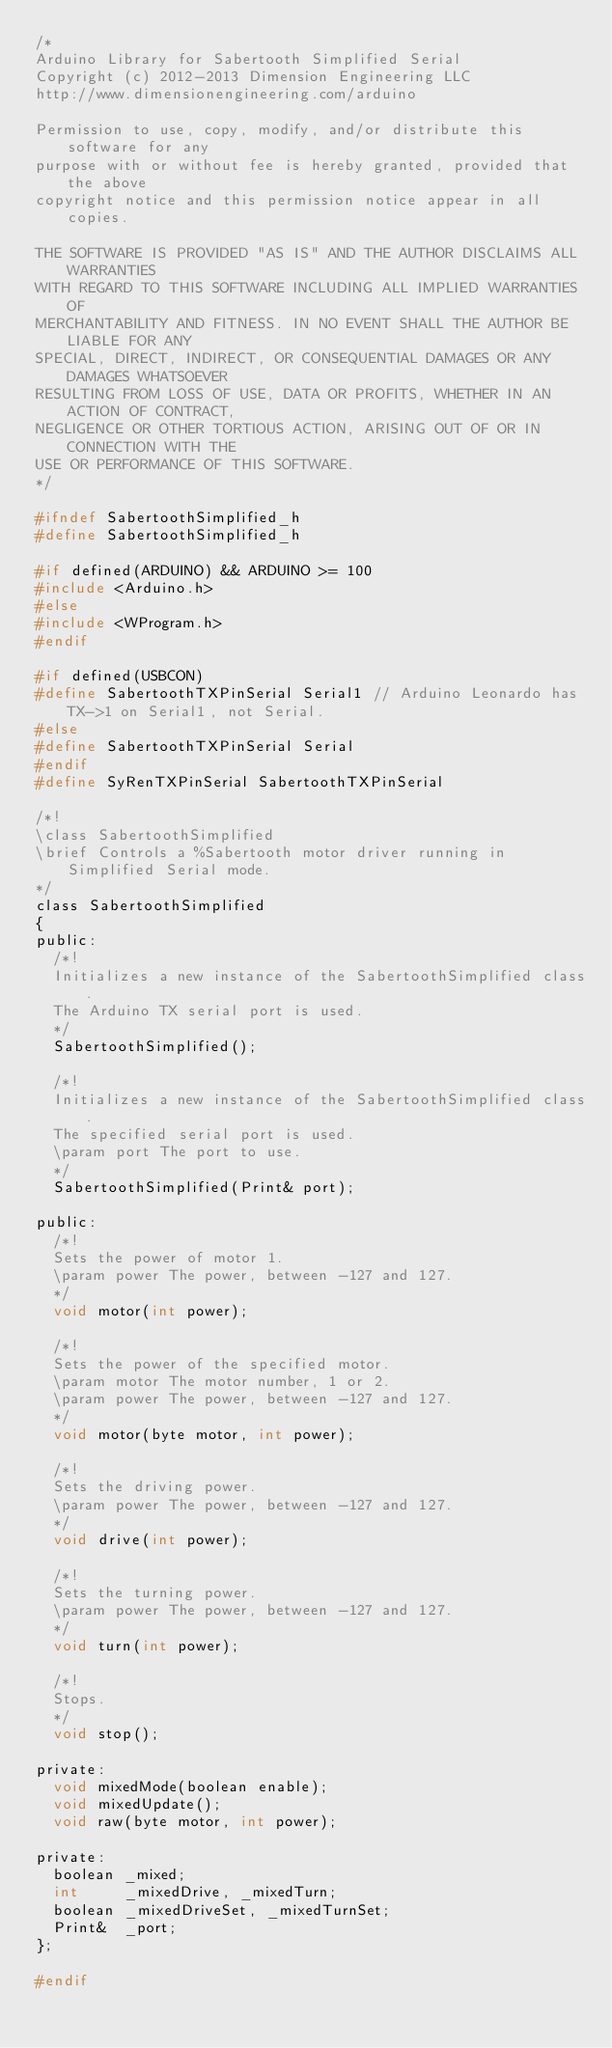<code> <loc_0><loc_0><loc_500><loc_500><_C_>/*
Arduino Library for Sabertooth Simplified Serial
Copyright (c) 2012-2013 Dimension Engineering LLC
http://www.dimensionengineering.com/arduino

Permission to use, copy, modify, and/or distribute this software for any
purpose with or without fee is hereby granted, provided that the above
copyright notice and this permission notice appear in all copies.

THE SOFTWARE IS PROVIDED "AS IS" AND THE AUTHOR DISCLAIMS ALL WARRANTIES
WITH REGARD TO THIS SOFTWARE INCLUDING ALL IMPLIED WARRANTIES OF
MERCHANTABILITY AND FITNESS. IN NO EVENT SHALL THE AUTHOR BE LIABLE FOR ANY
SPECIAL, DIRECT, INDIRECT, OR CONSEQUENTIAL DAMAGES OR ANY DAMAGES WHATSOEVER
RESULTING FROM LOSS OF USE, DATA OR PROFITS, WHETHER IN AN ACTION OF CONTRACT,
NEGLIGENCE OR OTHER TORTIOUS ACTION, ARISING OUT OF OR IN CONNECTION WITH THE
USE OR PERFORMANCE OF THIS SOFTWARE.
*/

#ifndef SabertoothSimplified_h
#define SabertoothSimplified_h   

#if defined(ARDUINO) && ARDUINO >= 100
#include <Arduino.h>
#else
#include <WProgram.h>
#endif

#if defined(USBCON)
#define SabertoothTXPinSerial Serial1 // Arduino Leonardo has TX->1 on Serial1, not Serial.
#else
#define SabertoothTXPinSerial Serial
#endif
#define SyRenTXPinSerial SabertoothTXPinSerial

/*!
\class SabertoothSimplified
\brief Controls a %Sabertooth motor driver running in Simplified Serial mode.
*/
class SabertoothSimplified
{
public:
  /*!
  Initializes a new instance of the SabertoothSimplified class.
  The Arduino TX serial port is used.
  */
  SabertoothSimplified();
  
  /*!
  Initializes a new instance of the SabertoothSimplified class.
  The specified serial port is used.
  \param port The port to use.
  */
  SabertoothSimplified(Print& port);

public:
  /*!
  Sets the power of motor 1.
  \param power The power, between -127 and 127.
  */
  void motor(int power);
  
  /*!
  Sets the power of the specified motor.
  \param motor The motor number, 1 or 2.
  \param power The power, between -127 and 127.
  */
  void motor(byte motor, int power);
  
  /*!
  Sets the driving power.
  \param power The power, between -127 and 127.
  */
  void drive(int power);
  
  /*!
  Sets the turning power.
  \param power The power, between -127 and 127.
  */
  void turn(int power);
  
  /*!
  Stops.
  */
  void stop();
  
private:
  void mixedMode(boolean enable);
  void mixedUpdate();
  void raw(byte motor, int power);
  
private:
  boolean _mixed;
  int     _mixedDrive, _mixedTurn;
  boolean _mixedDriveSet, _mixedTurnSet;
  Print&  _port;
};

#endif
</code> 